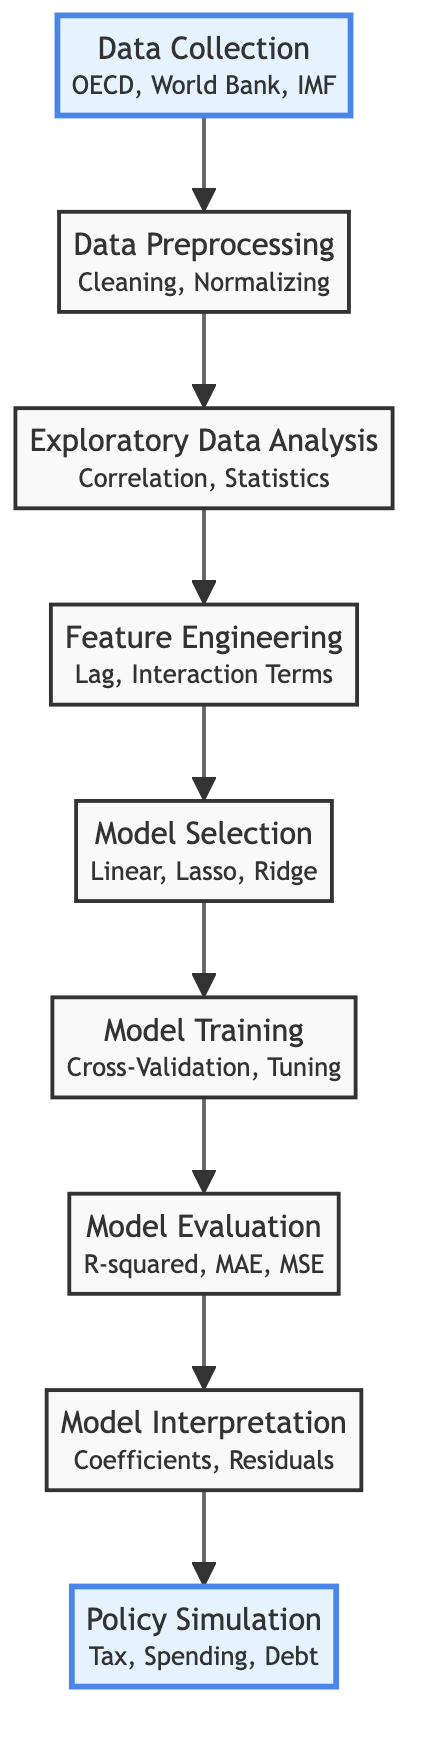What is the first step in the flowchart? The first step in the flowchart is labeled "Data Collection," which signifies the initial phase of the process. It is visually positioned at the top and is highlighted, indicating its importance.
Answer: Data Collection How many nodes are in the diagram? By counting each labeled node in the diagram, there are eight distinct nodes representing different stages of the analysis process.
Answer: Eight What follows the Data Preprocessing step? The node that directly follows "Data Preprocessing" is "Exploratory Data Analysis," indicating that after cleaning and normalizing the data, exploratory analysis is performed.
Answer: Exploratory Data Analysis Which step includes interaction terms? The step that includes "Interaction Terms" as part of its description is "Feature Engineering," which focuses on creating new features from the existing data.
Answer: Feature Engineering What type of model is selected after Feature Engineering? After the "Feature Engineering" step, the next step is "Model Selection," where various types of models such as linear, lasso, and ridge are evaluated.
Answer: Model Selection Which two steps are connected directly after Model Training? The two steps connected directly after "Model Training" are "Model Evaluation" and "Model Interpretation," showing the progression from training to assessing and interpreting the models.
Answer: Model Evaluation and Model Interpretation What is the last step in the flowchart? The last step in the flowchart is "Policy Simulation," which indicates that the final analysis involves simulating potential fiscal policies based on the regression results.
Answer: Policy Simulation How many specific evaluation metrics are mentioned? Three specific evaluation metrics are mentioned in the "Model Evaluation" step: R-squared, MAE, and MSE.
Answer: Three What is the primary focus of the diagram? The primary focus of the diagram is "Analyzing the Impact of Fiscal Policies on Economic Growth Through Regression Models," as stated in the title of the flowchart.
Answer: Analyzing the Impact of Fiscal Policies on Economic Growth Through Regression Models 